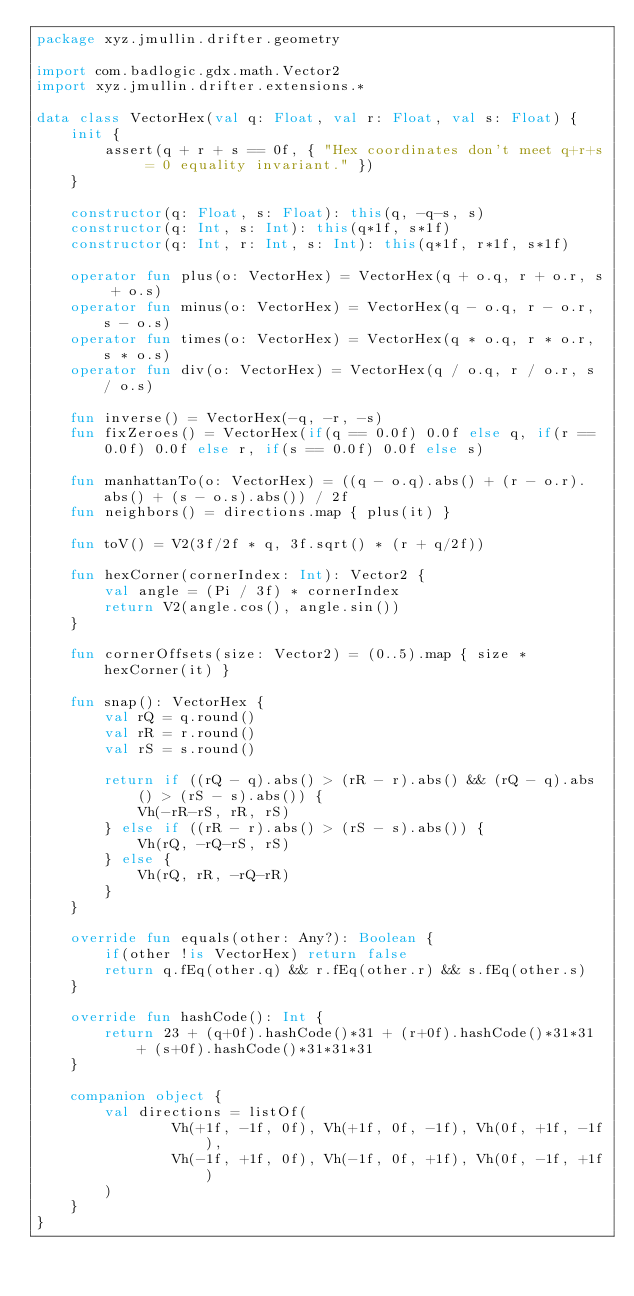<code> <loc_0><loc_0><loc_500><loc_500><_Kotlin_>package xyz.jmullin.drifter.geometry

import com.badlogic.gdx.math.Vector2
import xyz.jmullin.drifter.extensions.*

data class VectorHex(val q: Float, val r: Float, val s: Float) {
    init {
        assert(q + r + s == 0f, { "Hex coordinates don't meet q+r+s = 0 equality invariant." })
    }

    constructor(q: Float, s: Float): this(q, -q-s, s)
    constructor(q: Int, s: Int): this(q*1f, s*1f)
    constructor(q: Int, r: Int, s: Int): this(q*1f, r*1f, s*1f)

    operator fun plus(o: VectorHex) = VectorHex(q + o.q, r + o.r, s + o.s)
    operator fun minus(o: VectorHex) = VectorHex(q - o.q, r - o.r, s - o.s)
    operator fun times(o: VectorHex) = VectorHex(q * o.q, r * o.r, s * o.s)
    operator fun div(o: VectorHex) = VectorHex(q / o.q, r / o.r, s / o.s)

    fun inverse() = VectorHex(-q, -r, -s)
    fun fixZeroes() = VectorHex(if(q == 0.0f) 0.0f else q, if(r == 0.0f) 0.0f else r, if(s == 0.0f) 0.0f else s)

    fun manhattanTo(o: VectorHex) = ((q - o.q).abs() + (r - o.r).abs() + (s - o.s).abs()) / 2f
    fun neighbors() = directions.map { plus(it) }

    fun toV() = V2(3f/2f * q, 3f.sqrt() * (r + q/2f))

    fun hexCorner(cornerIndex: Int): Vector2 {
        val angle = (Pi / 3f) * cornerIndex
        return V2(angle.cos(), angle.sin())
    }

    fun cornerOffsets(size: Vector2) = (0..5).map { size * hexCorner(it) }

    fun snap(): VectorHex {
        val rQ = q.round()
        val rR = r.round()
        val rS = s.round()

        return if ((rQ - q).abs() > (rR - r).abs() && (rQ - q).abs() > (rS - s).abs()) {
            Vh(-rR-rS, rR, rS)
        } else if ((rR - r).abs() > (rS - s).abs()) {
            Vh(rQ, -rQ-rS, rS)
        } else {
            Vh(rQ, rR, -rQ-rR)
        }
    }

    override fun equals(other: Any?): Boolean {
        if(other !is VectorHex) return false
        return q.fEq(other.q) && r.fEq(other.r) && s.fEq(other.s)
    }

    override fun hashCode(): Int {
        return 23 + (q+0f).hashCode()*31 + (r+0f).hashCode()*31*31 + (s+0f).hashCode()*31*31*31
    }

    companion object {
        val directions = listOf(
                Vh(+1f, -1f, 0f), Vh(+1f, 0f, -1f), Vh(0f, +1f, -1f),
                Vh(-1f, +1f, 0f), Vh(-1f, 0f, +1f), Vh(0f, -1f, +1f)
        )
    }
}</code> 